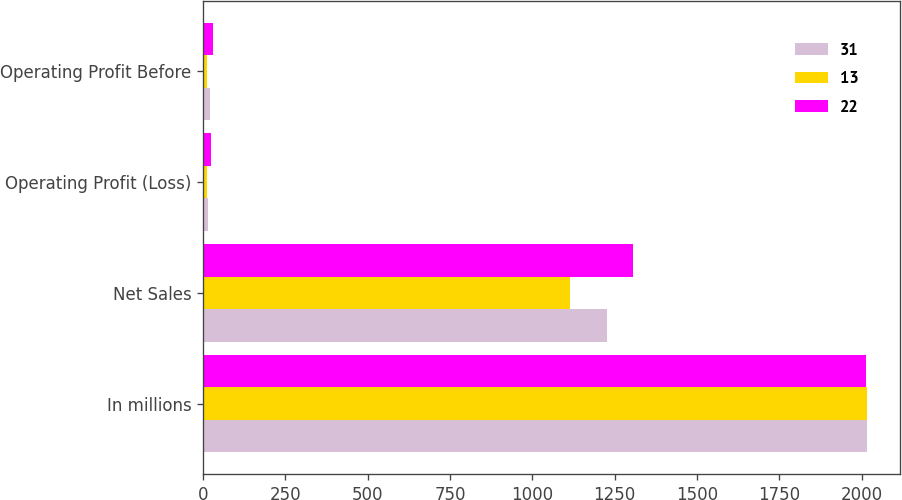Convert chart. <chart><loc_0><loc_0><loc_500><loc_500><stacked_bar_chart><ecel><fcel>In millions<fcel>Net Sales<fcel>Operating Profit (Loss)<fcel>Operating Profit Before<nl><fcel>31<fcel>2016<fcel>1227<fcel>15<fcel>22<nl><fcel>13<fcel>2015<fcel>1114<fcel>13<fcel>13<nl><fcel>22<fcel>2014<fcel>1307<fcel>25<fcel>31<nl></chart> 